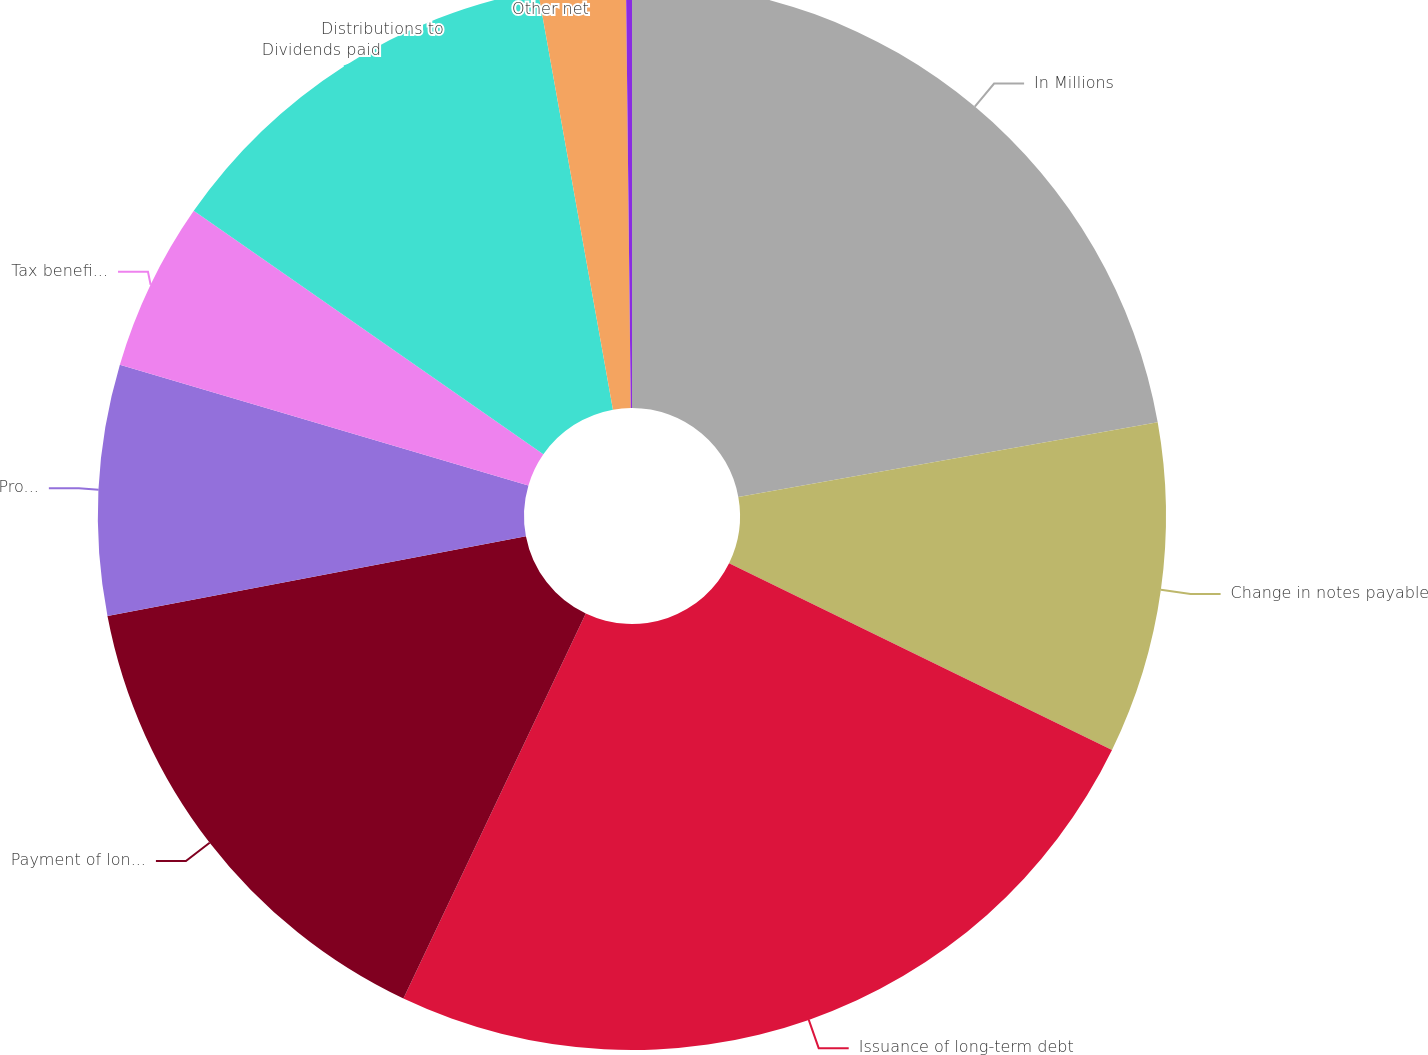Convert chart to OTSL. <chart><loc_0><loc_0><loc_500><loc_500><pie_chart><fcel>In Millions<fcel>Change in notes payable<fcel>Issuance of long-term debt<fcel>Payment of long-term debt<fcel>Proceeds from common stock<fcel>Tax benefit on exercised<fcel>Dividends paid<fcel>Distributions to<fcel>Other net<nl><fcel>22.19%<fcel>10.03%<fcel>24.82%<fcel>14.96%<fcel>7.57%<fcel>5.11%<fcel>12.5%<fcel>2.64%<fcel>0.18%<nl></chart> 